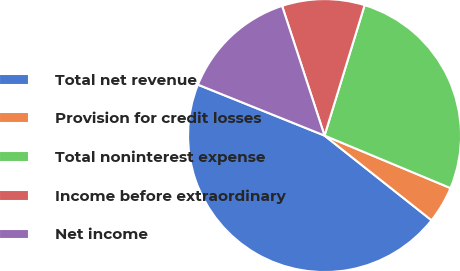<chart> <loc_0><loc_0><loc_500><loc_500><pie_chart><fcel>Total net revenue<fcel>Provision for credit losses<fcel>Total noninterest expense<fcel>Income before extraordinary<fcel>Net income<nl><fcel>45.43%<fcel>4.37%<fcel>26.54%<fcel>9.78%<fcel>13.88%<nl></chart> 